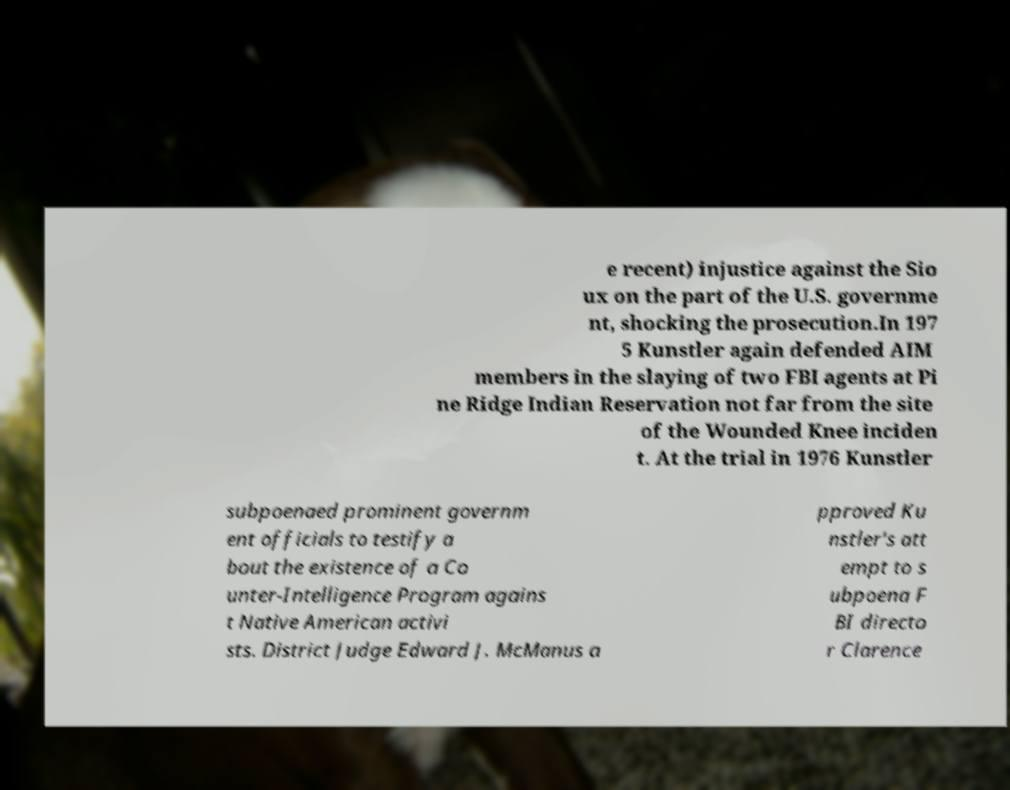Could you assist in decoding the text presented in this image and type it out clearly? e recent) injustice against the Sio ux on the part of the U.S. governme nt, shocking the prosecution.In 197 5 Kunstler again defended AIM members in the slaying of two FBI agents at Pi ne Ridge Indian Reservation not far from the site of the Wounded Knee inciden t. At the trial in 1976 Kunstler subpoenaed prominent governm ent officials to testify a bout the existence of a Co unter-Intelligence Program agains t Native American activi sts. District Judge Edward J. McManus a pproved Ku nstler's att empt to s ubpoena F BI directo r Clarence 